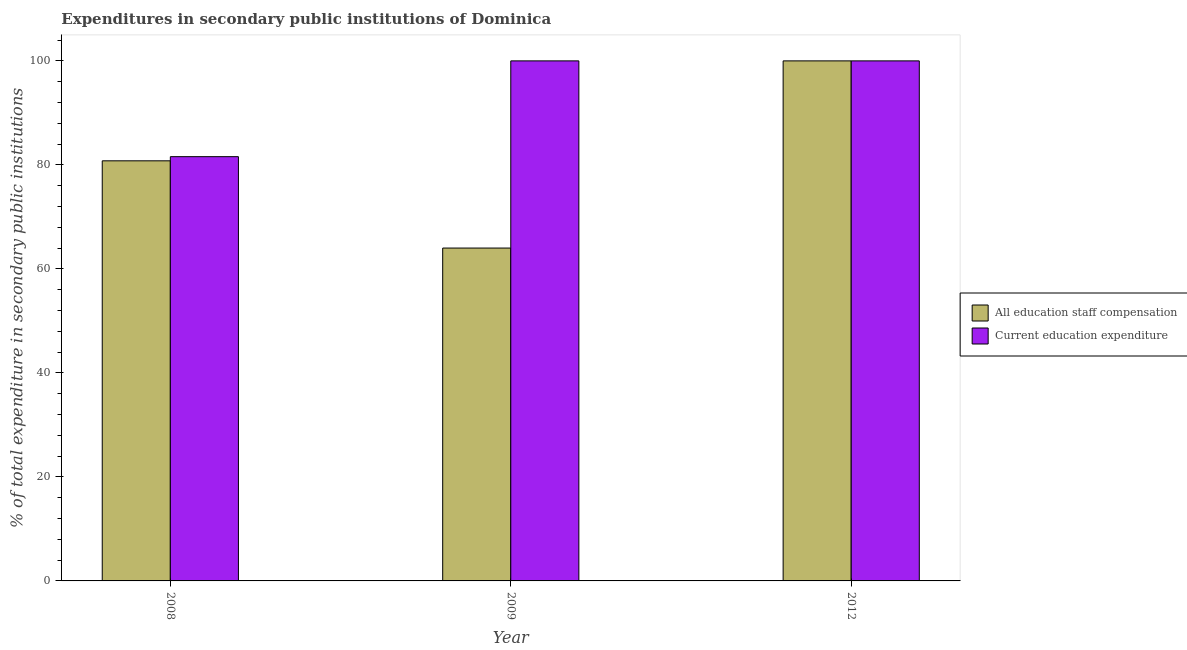How many different coloured bars are there?
Your answer should be very brief. 2. How many groups of bars are there?
Provide a succinct answer. 3. Are the number of bars per tick equal to the number of legend labels?
Provide a succinct answer. Yes. How many bars are there on the 3rd tick from the left?
Make the answer very short. 2. What is the label of the 2nd group of bars from the left?
Your response must be concise. 2009. In how many cases, is the number of bars for a given year not equal to the number of legend labels?
Your response must be concise. 0. What is the expenditure in education in 2012?
Make the answer very short. 100. Across all years, what is the minimum expenditure in education?
Make the answer very short. 81.58. What is the total expenditure in staff compensation in the graph?
Offer a very short reply. 244.79. What is the difference between the expenditure in staff compensation in 2012 and the expenditure in education in 2009?
Keep it short and to the point. 35.99. What is the average expenditure in education per year?
Provide a short and direct response. 93.86. In how many years, is the expenditure in staff compensation greater than 84 %?
Offer a terse response. 1. What is the ratio of the expenditure in education in 2008 to that in 2009?
Provide a short and direct response. 0.82. Is the expenditure in education in 2008 less than that in 2009?
Keep it short and to the point. Yes. Is the difference between the expenditure in education in 2008 and 2012 greater than the difference between the expenditure in staff compensation in 2008 and 2012?
Offer a terse response. No. What is the difference between the highest and the second highest expenditure in education?
Keep it short and to the point. 0. What is the difference between the highest and the lowest expenditure in education?
Make the answer very short. 18.42. Is the sum of the expenditure in education in 2008 and 2012 greater than the maximum expenditure in staff compensation across all years?
Keep it short and to the point. Yes. What does the 2nd bar from the left in 2008 represents?
Provide a succinct answer. Current education expenditure. What does the 2nd bar from the right in 2009 represents?
Offer a very short reply. All education staff compensation. Are all the bars in the graph horizontal?
Provide a succinct answer. No. Are the values on the major ticks of Y-axis written in scientific E-notation?
Ensure brevity in your answer.  No. Does the graph contain any zero values?
Offer a terse response. No. Does the graph contain grids?
Provide a short and direct response. No. What is the title of the graph?
Your response must be concise. Expenditures in secondary public institutions of Dominica. What is the label or title of the X-axis?
Your answer should be compact. Year. What is the label or title of the Y-axis?
Keep it short and to the point. % of total expenditure in secondary public institutions. What is the % of total expenditure in secondary public institutions in All education staff compensation in 2008?
Provide a short and direct response. 80.78. What is the % of total expenditure in secondary public institutions of Current education expenditure in 2008?
Offer a terse response. 81.58. What is the % of total expenditure in secondary public institutions in All education staff compensation in 2009?
Make the answer very short. 64.01. What is the % of total expenditure in secondary public institutions in Current education expenditure in 2009?
Your response must be concise. 100. What is the % of total expenditure in secondary public institutions in All education staff compensation in 2012?
Your answer should be compact. 100. Across all years, what is the minimum % of total expenditure in secondary public institutions in All education staff compensation?
Offer a terse response. 64.01. Across all years, what is the minimum % of total expenditure in secondary public institutions of Current education expenditure?
Make the answer very short. 81.58. What is the total % of total expenditure in secondary public institutions in All education staff compensation in the graph?
Offer a terse response. 244.79. What is the total % of total expenditure in secondary public institutions in Current education expenditure in the graph?
Make the answer very short. 281.58. What is the difference between the % of total expenditure in secondary public institutions in All education staff compensation in 2008 and that in 2009?
Your response must be concise. 16.78. What is the difference between the % of total expenditure in secondary public institutions of Current education expenditure in 2008 and that in 2009?
Your answer should be very brief. -18.42. What is the difference between the % of total expenditure in secondary public institutions of All education staff compensation in 2008 and that in 2012?
Make the answer very short. -19.22. What is the difference between the % of total expenditure in secondary public institutions in Current education expenditure in 2008 and that in 2012?
Provide a succinct answer. -18.42. What is the difference between the % of total expenditure in secondary public institutions in All education staff compensation in 2009 and that in 2012?
Provide a short and direct response. -35.99. What is the difference between the % of total expenditure in secondary public institutions of Current education expenditure in 2009 and that in 2012?
Your answer should be compact. 0. What is the difference between the % of total expenditure in secondary public institutions in All education staff compensation in 2008 and the % of total expenditure in secondary public institutions in Current education expenditure in 2009?
Offer a terse response. -19.22. What is the difference between the % of total expenditure in secondary public institutions of All education staff compensation in 2008 and the % of total expenditure in secondary public institutions of Current education expenditure in 2012?
Your answer should be compact. -19.22. What is the difference between the % of total expenditure in secondary public institutions in All education staff compensation in 2009 and the % of total expenditure in secondary public institutions in Current education expenditure in 2012?
Provide a succinct answer. -35.99. What is the average % of total expenditure in secondary public institutions in All education staff compensation per year?
Ensure brevity in your answer.  81.6. What is the average % of total expenditure in secondary public institutions in Current education expenditure per year?
Give a very brief answer. 93.86. In the year 2008, what is the difference between the % of total expenditure in secondary public institutions of All education staff compensation and % of total expenditure in secondary public institutions of Current education expenditure?
Ensure brevity in your answer.  -0.8. In the year 2009, what is the difference between the % of total expenditure in secondary public institutions in All education staff compensation and % of total expenditure in secondary public institutions in Current education expenditure?
Provide a succinct answer. -35.99. In the year 2012, what is the difference between the % of total expenditure in secondary public institutions in All education staff compensation and % of total expenditure in secondary public institutions in Current education expenditure?
Your answer should be compact. 0. What is the ratio of the % of total expenditure in secondary public institutions in All education staff compensation in 2008 to that in 2009?
Provide a short and direct response. 1.26. What is the ratio of the % of total expenditure in secondary public institutions of Current education expenditure in 2008 to that in 2009?
Your answer should be compact. 0.82. What is the ratio of the % of total expenditure in secondary public institutions in All education staff compensation in 2008 to that in 2012?
Offer a very short reply. 0.81. What is the ratio of the % of total expenditure in secondary public institutions of Current education expenditure in 2008 to that in 2012?
Give a very brief answer. 0.82. What is the ratio of the % of total expenditure in secondary public institutions in All education staff compensation in 2009 to that in 2012?
Your response must be concise. 0.64. What is the difference between the highest and the second highest % of total expenditure in secondary public institutions in All education staff compensation?
Provide a succinct answer. 19.22. What is the difference between the highest and the second highest % of total expenditure in secondary public institutions in Current education expenditure?
Give a very brief answer. 0. What is the difference between the highest and the lowest % of total expenditure in secondary public institutions in All education staff compensation?
Offer a terse response. 35.99. What is the difference between the highest and the lowest % of total expenditure in secondary public institutions in Current education expenditure?
Make the answer very short. 18.42. 